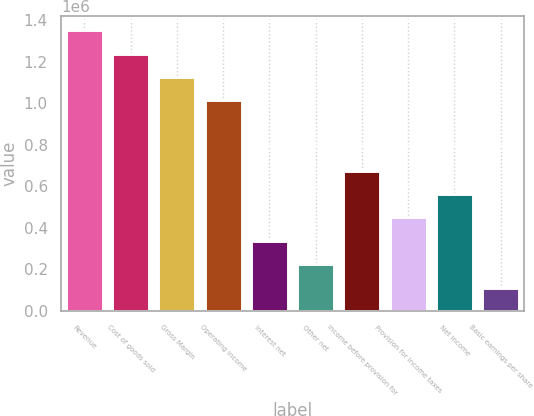<chart> <loc_0><loc_0><loc_500><loc_500><bar_chart><fcel>Revenue<fcel>Cost of goods sold<fcel>Gross Margin<fcel>Operating income<fcel>Interest net<fcel>Other net<fcel>Income before provision for<fcel>Provision for income taxes<fcel>Net income<fcel>Basic earnings per share<nl><fcel>1.35219e+06<fcel>1.23951e+06<fcel>1.12683e+06<fcel>1.01414e+06<fcel>338048<fcel>225365<fcel>676095<fcel>450730<fcel>563413<fcel>112683<nl></chart> 